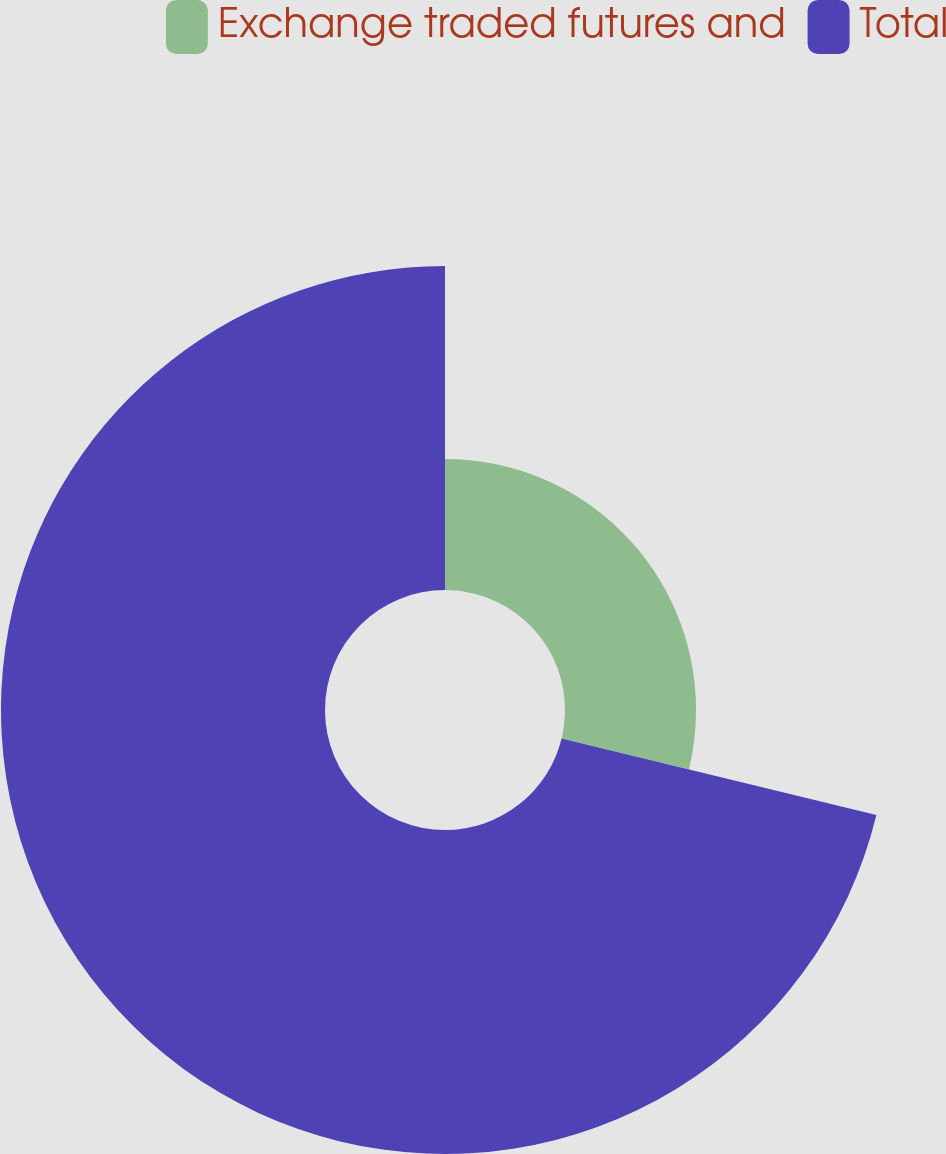<chart> <loc_0><loc_0><loc_500><loc_500><pie_chart><fcel>Exchange traded futures and<fcel>Total<nl><fcel>28.8%<fcel>71.2%<nl></chart> 